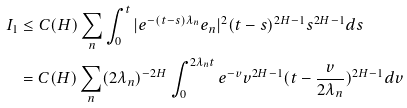Convert formula to latex. <formula><loc_0><loc_0><loc_500><loc_500>I _ { 1 } & \leq C ( H ) \sum _ { n } \int _ { 0 } ^ { t } | e ^ { - ( t - s ) \lambda _ { n } } e _ { n } | ^ { 2 } ( t - s ) ^ { 2 H - 1 } s ^ { 2 H - 1 } d s \\ & = C ( H ) \sum _ { n } ( 2 \lambda _ { n } ) ^ { - 2 H } \int _ { 0 } ^ { 2 \lambda _ { n } t } e ^ { - v } v ^ { 2 H - 1 } ( t - \frac { v } { 2 \lambda _ { n } } ) ^ { 2 H - 1 } d v</formula> 